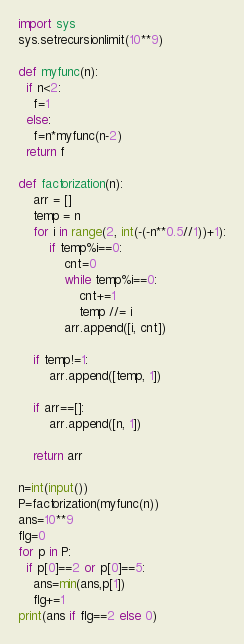Convert code to text. <code><loc_0><loc_0><loc_500><loc_500><_Python_>import sys
sys.setrecursionlimit(10**9)

def myfunc(n):
  if n<2:
    f=1
  else:
    f=n*myfunc(n-2)
  return f

def factorization(n):
    arr = []
    temp = n
    for i in range(2, int(-(-n**0.5//1))+1):
        if temp%i==0:
            cnt=0
            while temp%i==0:
                cnt+=1
                temp //= i
            arr.append([i, cnt])

    if temp!=1:
        arr.append([temp, 1])

    if arr==[]:
        arr.append([n, 1])

    return arr

n=int(input())
P=factorization(myfunc(n))
ans=10**9
flg=0
for p in P:
  if p[0]==2 or p[0]==5:
    ans=min(ans,p[1])
    flg+=1
print(ans if flg==2 else 0)</code> 